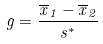Convert formula to latex. <formula><loc_0><loc_0><loc_500><loc_500>g = \frac { \overline { x } _ { 1 } - \overline { x } _ { 2 } } { s ^ { * } }</formula> 